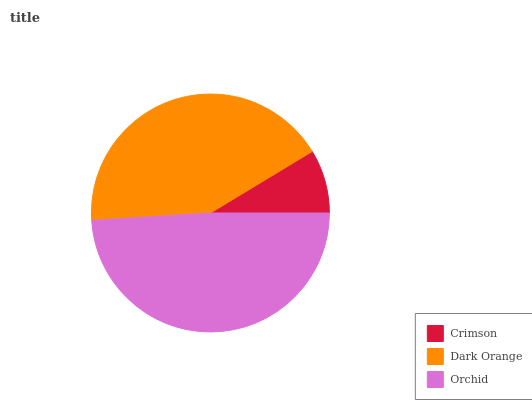Is Crimson the minimum?
Answer yes or no. Yes. Is Orchid the maximum?
Answer yes or no. Yes. Is Dark Orange the minimum?
Answer yes or no. No. Is Dark Orange the maximum?
Answer yes or no. No. Is Dark Orange greater than Crimson?
Answer yes or no. Yes. Is Crimson less than Dark Orange?
Answer yes or no. Yes. Is Crimson greater than Dark Orange?
Answer yes or no. No. Is Dark Orange less than Crimson?
Answer yes or no. No. Is Dark Orange the high median?
Answer yes or no. Yes. Is Dark Orange the low median?
Answer yes or no. Yes. Is Crimson the high median?
Answer yes or no. No. Is Crimson the low median?
Answer yes or no. No. 